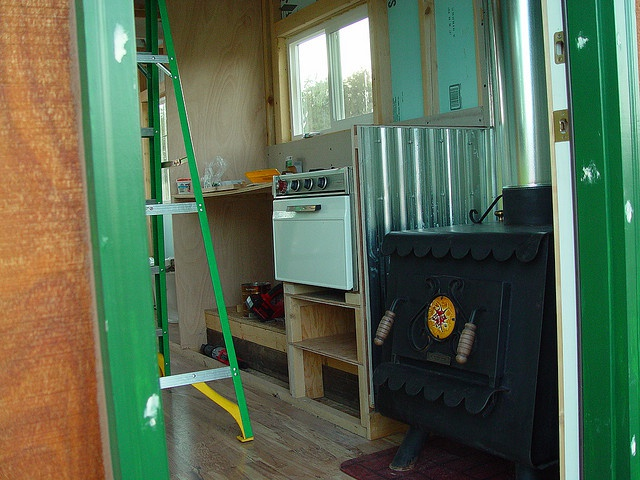Describe the objects in this image and their specific colors. I can see microwave in olive, black, gray, and teal tones and oven in olive, darkgray, gray, and black tones in this image. 